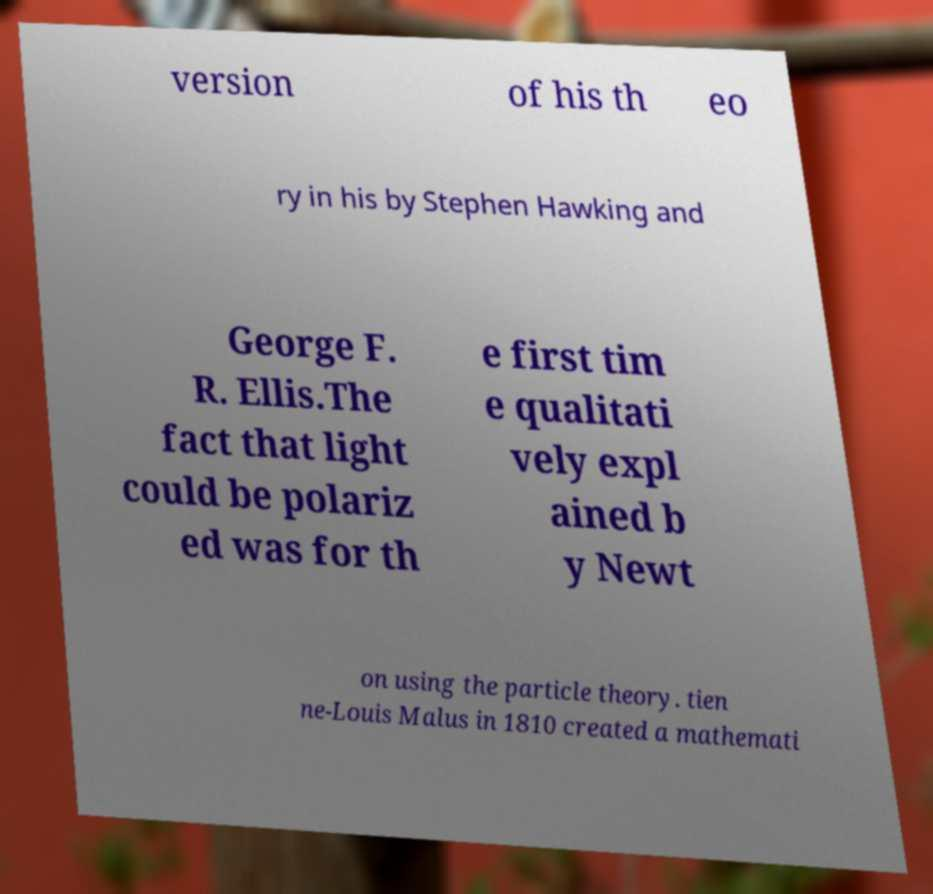For documentation purposes, I need the text within this image transcribed. Could you provide that? version of his th eo ry in his by Stephen Hawking and George F. R. Ellis.The fact that light could be polariz ed was for th e first tim e qualitati vely expl ained b y Newt on using the particle theory. tien ne-Louis Malus in 1810 created a mathemati 